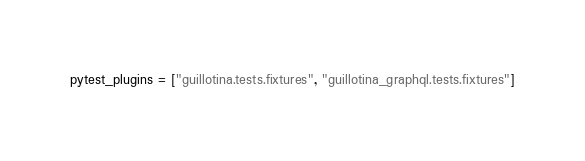Convert code to text. <code><loc_0><loc_0><loc_500><loc_500><_Python_>pytest_plugins = ["guillotina.tests.fixtures", "guillotina_graphql.tests.fixtures"]
</code> 